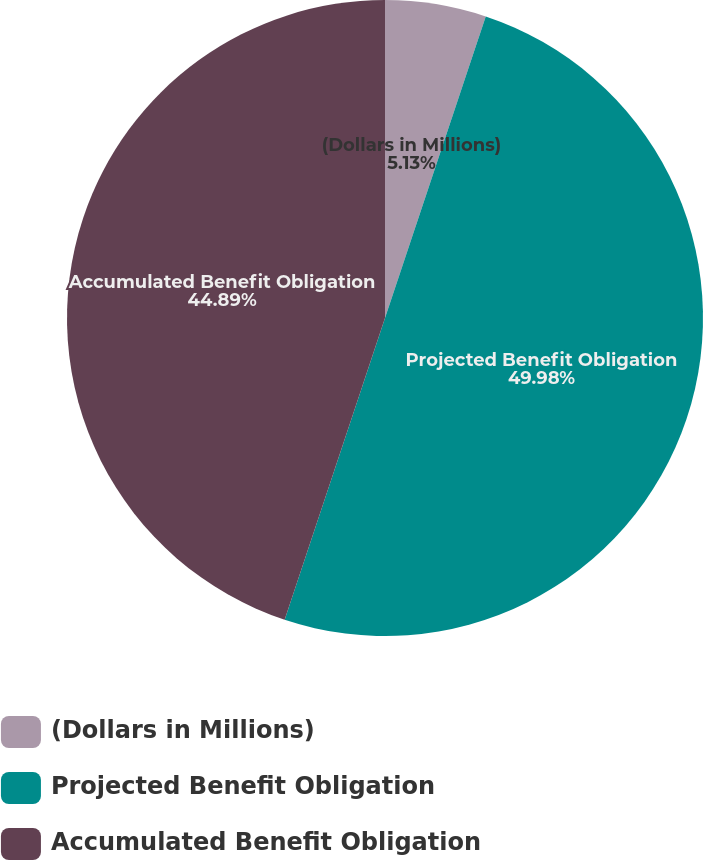Convert chart. <chart><loc_0><loc_0><loc_500><loc_500><pie_chart><fcel>(Dollars in Millions)<fcel>Projected Benefit Obligation<fcel>Accumulated Benefit Obligation<nl><fcel>5.13%<fcel>49.98%<fcel>44.89%<nl></chart> 